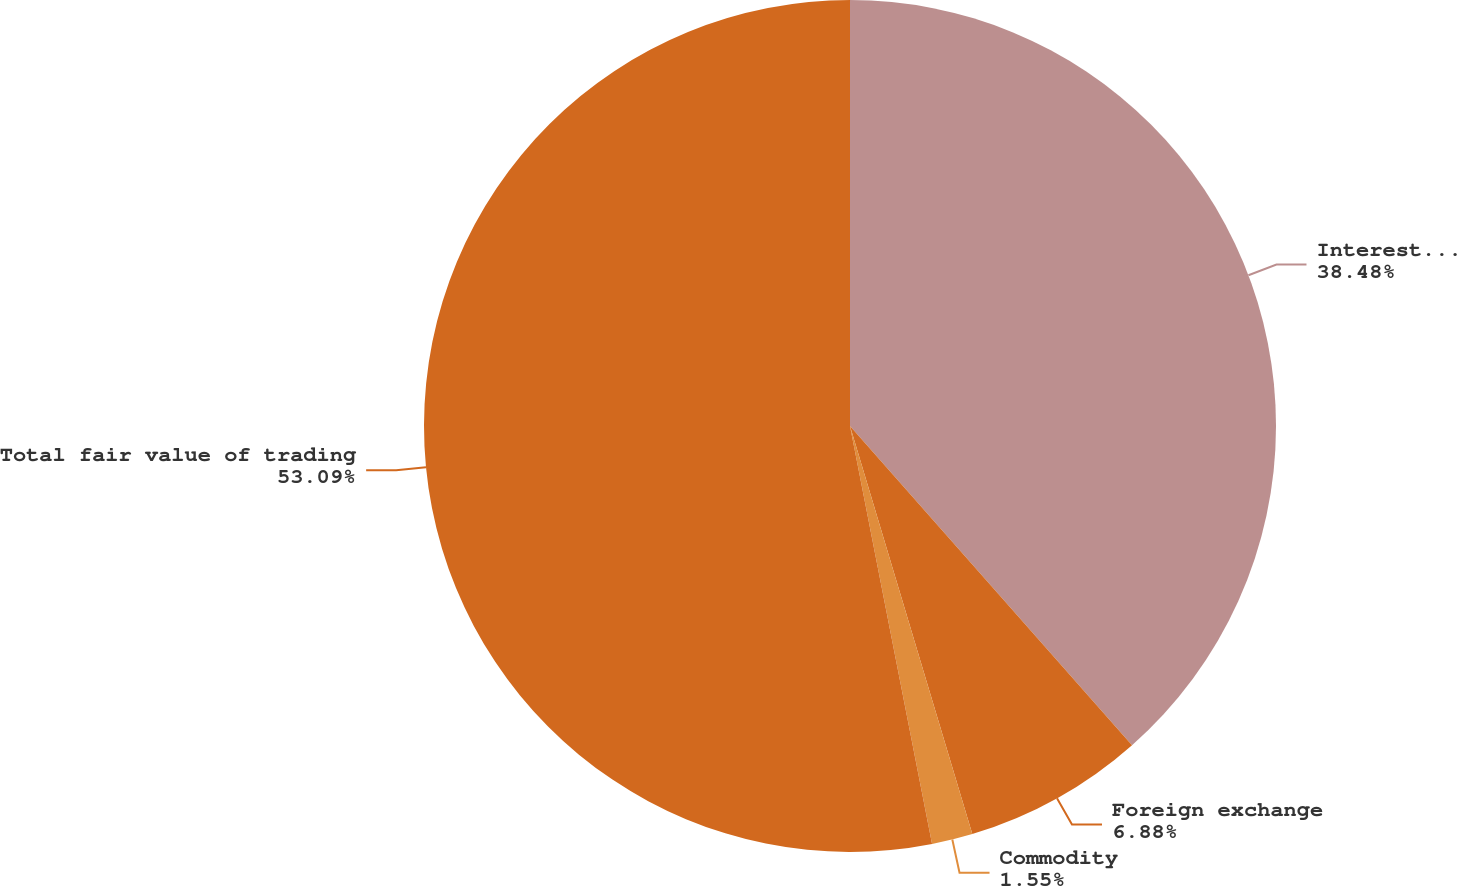<chart> <loc_0><loc_0><loc_500><loc_500><pie_chart><fcel>Interest rate<fcel>Foreign exchange<fcel>Commodity<fcel>Total fair value of trading<nl><fcel>38.48%<fcel>6.88%<fcel>1.55%<fcel>53.08%<nl></chart> 